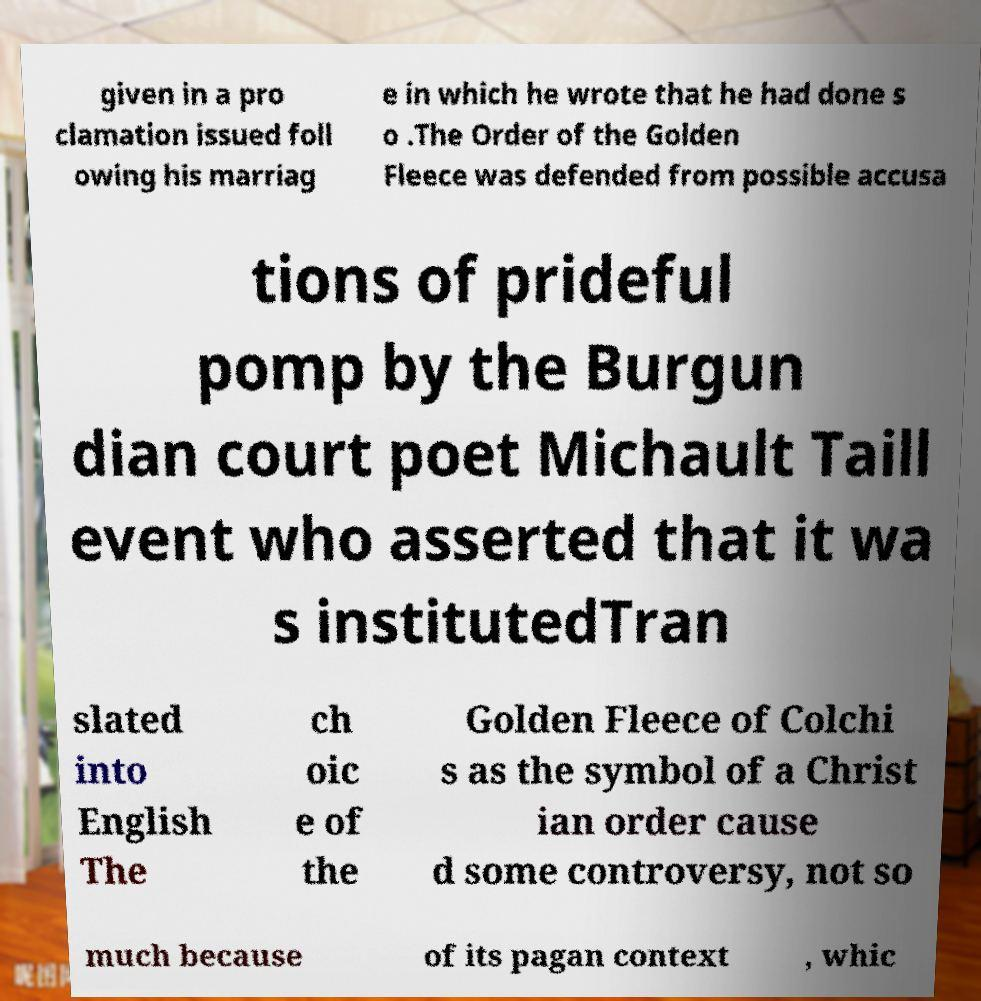What messages or text are displayed in this image? I need them in a readable, typed format. given in a pro clamation issued foll owing his marriag e in which he wrote that he had done s o .The Order of the Golden Fleece was defended from possible accusa tions of prideful pomp by the Burgun dian court poet Michault Taill event who asserted that it wa s institutedTran slated into English The ch oic e of the Golden Fleece of Colchi s as the symbol of a Christ ian order cause d some controversy, not so much because of its pagan context , whic 